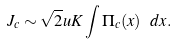<formula> <loc_0><loc_0><loc_500><loc_500>J _ { c } \sim \sqrt { 2 } u K \int \Pi _ { c } ( x ) \ d x .</formula> 